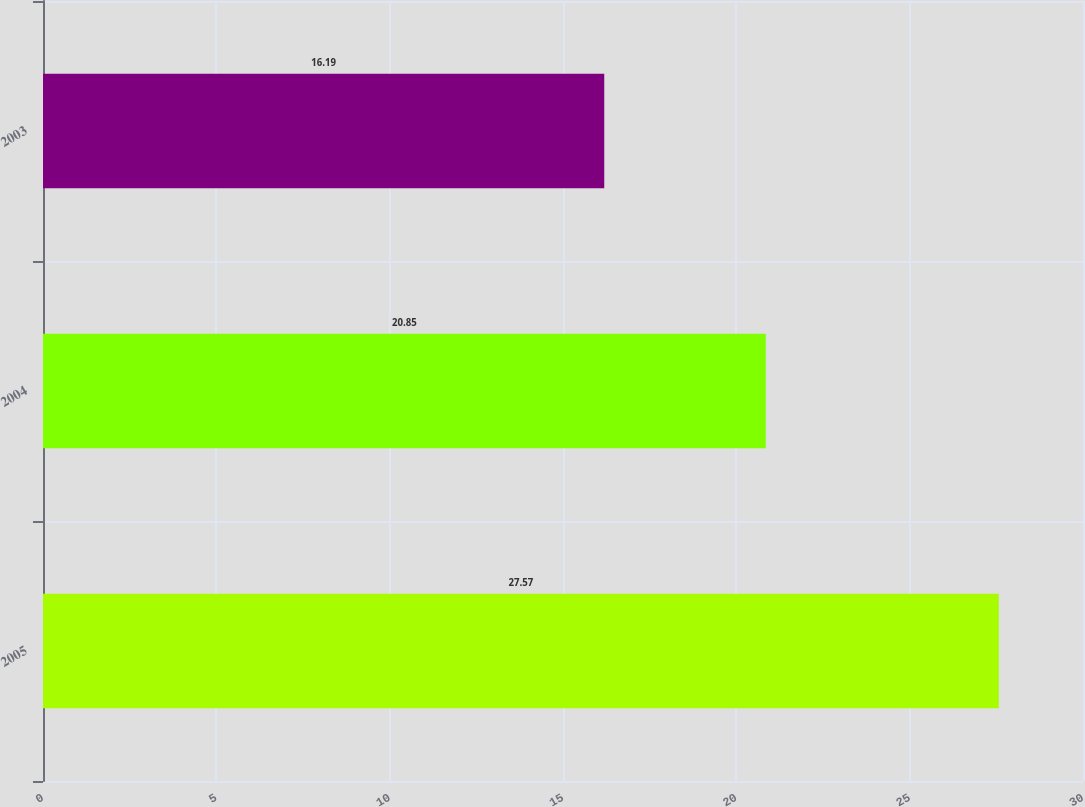<chart> <loc_0><loc_0><loc_500><loc_500><bar_chart><fcel>2005<fcel>2004<fcel>2003<nl><fcel>27.57<fcel>20.85<fcel>16.19<nl></chart> 